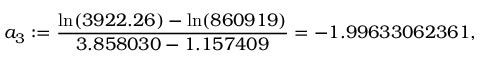<formula> <loc_0><loc_0><loc_500><loc_500>a _ { 3 } \colon = \frac { \ln ( 3 9 2 2 . 2 6 ) - \ln ( 8 6 0 9 1 9 ) } { 3 . 8 5 8 0 3 0 - 1 . 1 5 7 4 0 9 } = - 1 . 9 9 6 3 3 0 6 2 3 6 1 ,</formula> 